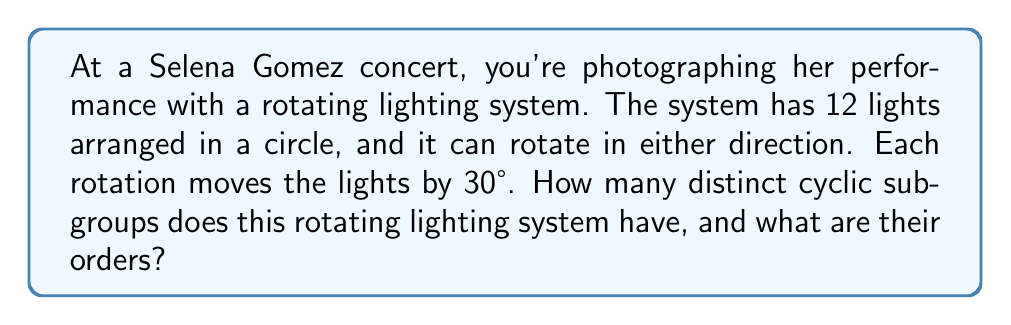Give your solution to this math problem. To solve this problem, we need to analyze the cyclic subgroups of the rotating lighting system. Let's approach this step-by-step:

1) First, we need to understand the group structure. The rotating lighting system forms a cyclic group of order 12, which we can denote as $C_{12}$.

2) The number of distinct cyclic subgroups is equal to the number of divisors of the group's order. The divisors of 12 are 1, 2, 3, 4, 6, and 12.

3) For each divisor $d$ of 12, there is a unique subgroup of order $d$. Let's examine each:

   a) $d = 1$: The trivial subgroup $\{e\}$ (no rotation)
   b) $d = 2$: Subgroup $\{e, r^6\}$ (rotations by 0° and 180°)
   c) $d = 3$: Subgroup $\{e, r^4, r^8\}$ (rotations by 0°, 120°, 240°)
   d) $d = 4$: Subgroup $\{e, r^3, r^6, r^9\}$ (rotations by 0°, 90°, 180°, 270°)
   e) $d = 6$: Subgroup $\{e, r^2, r^4, r^6, r^8, r^{10}\}$ (rotations by multiples of 60°)
   f) $d = 12$: The entire group $C_{12}$ (all possible rotations)

   Here, $r$ represents a rotation by 30°, and $r^n$ represents $n$ consecutive 30° rotations.

4) Therefore, there are 6 distinct cyclic subgroups.

5) The orders of these subgroups are 1, 2, 3, 4, 6, and 12, respectively.

As a photographer, understanding these subgroups could help you predict the lighting patterns and plan your shots accordingly.
Answer: The rotating lighting system has 6 distinct cyclic subgroups with orders 1, 2, 3, 4, 6, and 12. 